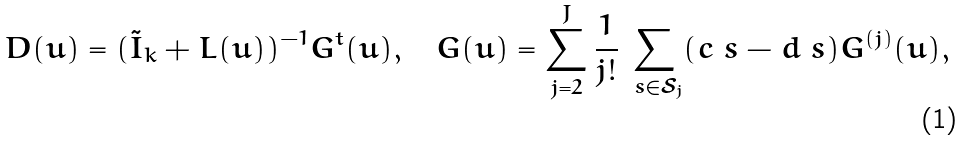Convert formula to latex. <formula><loc_0><loc_0><loc_500><loc_500>D ( u ) = ( \tilde { I } _ { k } + L ( u ) ) ^ { - 1 } G ^ { t } ( u ) , \quad G ( u ) = \sum _ { j = 2 } ^ { J } \frac { 1 } { j ! } \sum _ { \ s \in \mathcal { S } _ { j } } ( c _ { \ } s - d _ { \ } s ) G ^ { ( j ) } ( u ) ,</formula> 